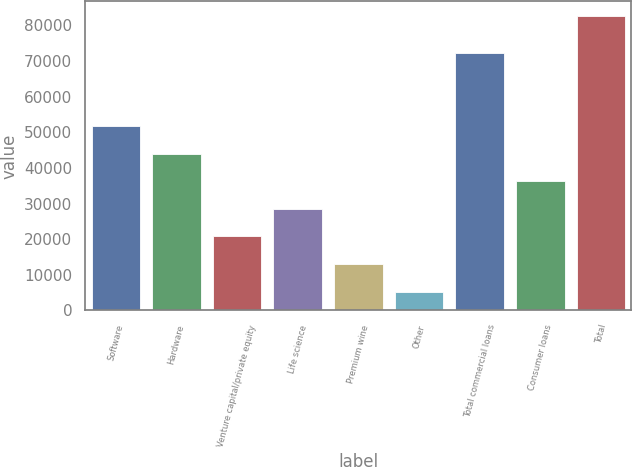Convert chart to OTSL. <chart><loc_0><loc_0><loc_500><loc_500><bar_chart><fcel>Software<fcel>Hardware<fcel>Venture capital/private equity<fcel>Life science<fcel>Premium wine<fcel>Other<fcel>Total commercial loans<fcel>Consumer loans<fcel>Total<nl><fcel>51703.4<fcel>43972.5<fcel>20779.8<fcel>28510.7<fcel>13048.9<fcel>5318<fcel>72104<fcel>36241.6<fcel>82627<nl></chart> 